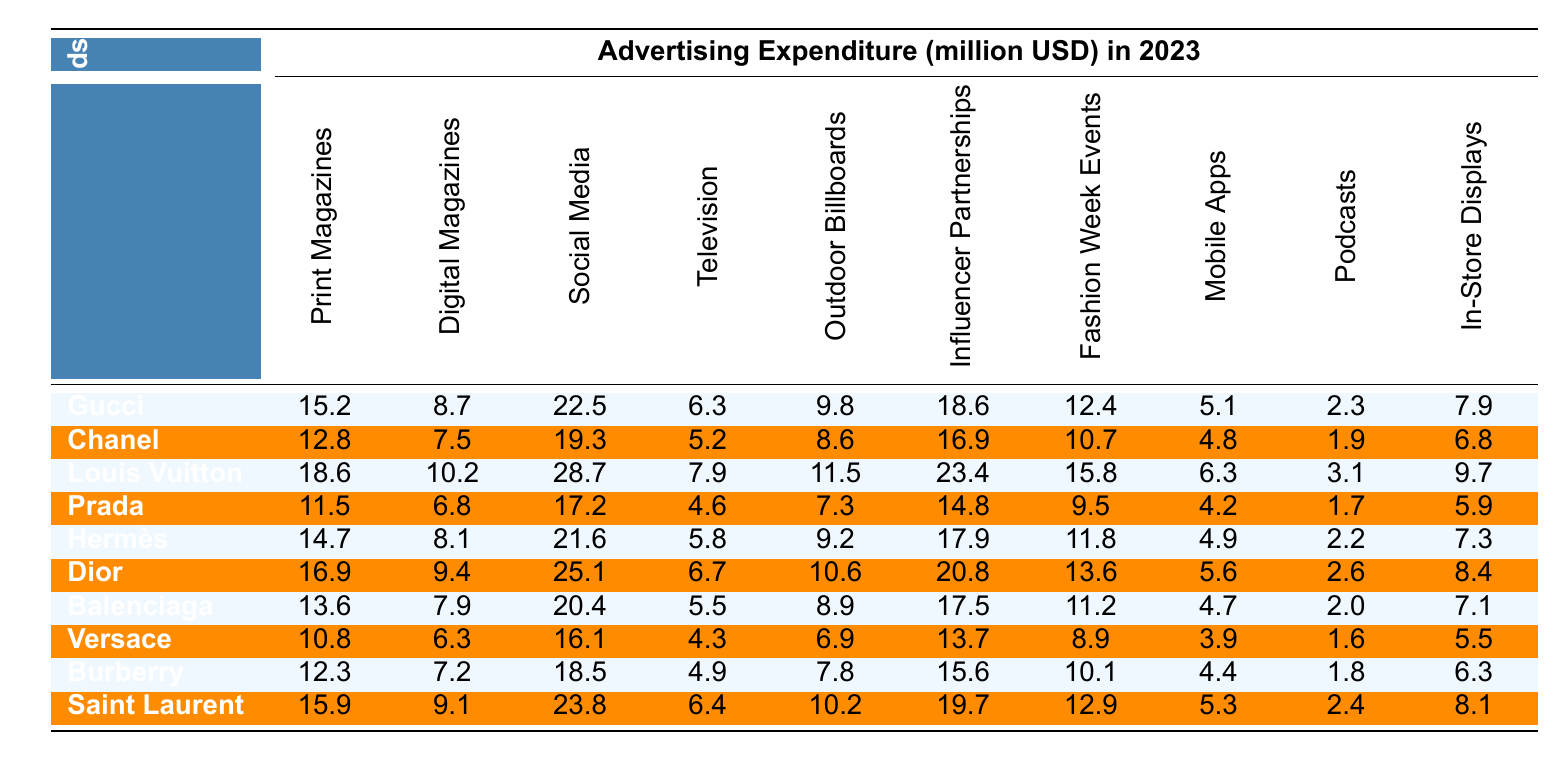What is the highest advertising expenditure among the brands? By examining the expenditures listed for each brand, Louis Vuitton has the highest expenditure at 28.7 million USD in Social Media.
Answer: 28.7 million USD Which brand spends the least on Outdoor Billboards? Looking at the Outdoor Billboards expenditures, Versace spends the least at 6.9 million USD.
Answer: Versace What is the total expenditure of Gucci across all platforms? Summing Gucci's expenditures: 15.2 + 8.7 + 22.5 + 6.3 + 9.8 + 18.6 + 12.4 + 5.1 + 2.3 + 7.9 = 110.8 million USD.
Answer: 110.8 million USD Which brand has a higher expenditure on Digital Magazines, Chanel or Prada? Chanel spends 7.5 million USD and Prada spends 6.8 million USD on Digital Magazines. Since 7.5 > 6.8, Chanel has the higher expenditure.
Answer: Chanel What is the average expenditure on Print Magazines across all brands? The total expenditure on Print Magazines is 15.2 + 12.8 + 18.6 + 11.5 + 14.7 + 16.9 + 13.6 + 10.8 + 12.3 + 15.9 =  139.2 million USD. There are 10 brands, so the average is 139.2 / 10 = 13.92 million USD.
Answer: 13.92 million USD Is Hermès' spending on Fashion Week Events greater than that of Dior? Hermès spends 11.8 million USD and Dior spends 13.6 million USD on Fashion Week Events. Since 11.8 < 13.6, Hermès' expenditure is not greater.
Answer: No Which brand has the highest expenditure on Influencer Partnerships? Comparing the expenditures on Influencer Partnerships, Louis Vuitton spends the most at 23.4 million USD.
Answer: Louis Vuitton What is the total expenditure on Social Media for all brands combined? Summing the expenditures for Social Media: 22.5 + 19.3 + 28.7 + 17.2 + 21.6 + 25.1 + 20.4 + 16.1 + 18.5 + 23.8 =  213.6 million USD.
Answer: 213.6 million USD Which platform has the lowest expenditure among the brands altogether? Looking at the expenditures, Podcasts have the lowest total expenditure of 2.4 + 1.9 + 3.1 + 1.7 + 2.2 + 2.6 + 2.0 + 1.6 + 1.8 + 2.4 =  19.5 million USD.
Answer: Podcasts Which brand spends the same amount on In-Store Displays as Burberry? Burberry spends 6.3 million USD on In-Store Displays, while Gucci also spends 7.9 million USD. No other brand has the same expenditure.
Answer: No brand has the same expenditure as Burberry 